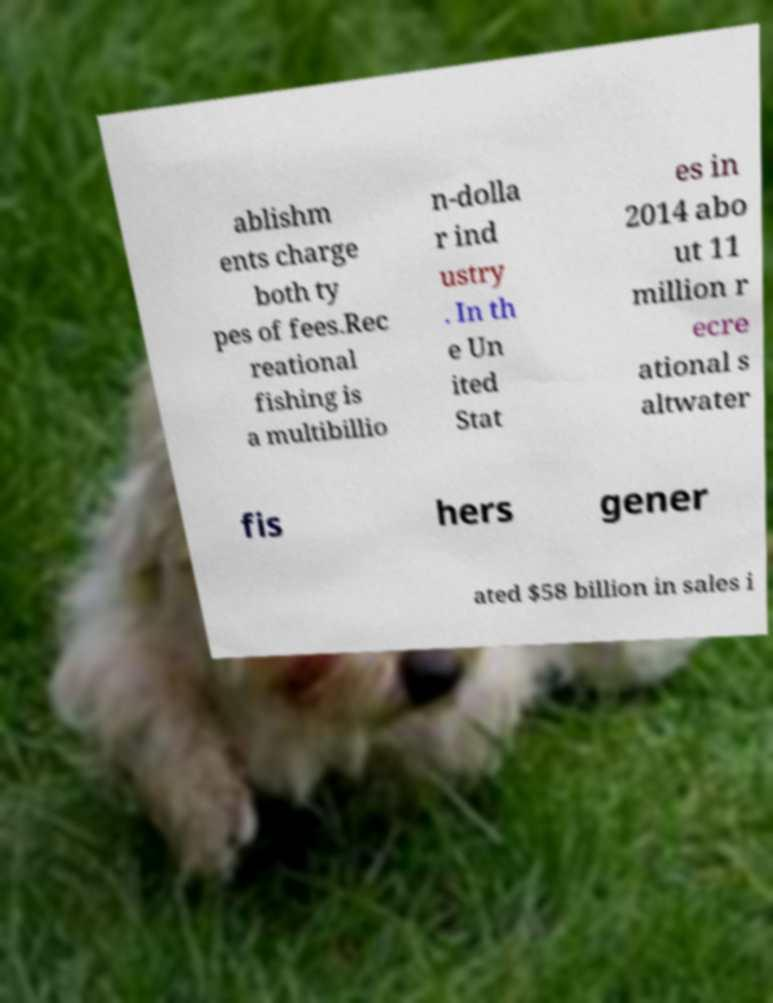What messages or text are displayed in this image? I need them in a readable, typed format. ablishm ents charge both ty pes of fees.Rec reational fishing is a multibillio n-dolla r ind ustry . In th e Un ited Stat es in 2014 abo ut 11 million r ecre ational s altwater fis hers gener ated $58 billion in sales i 